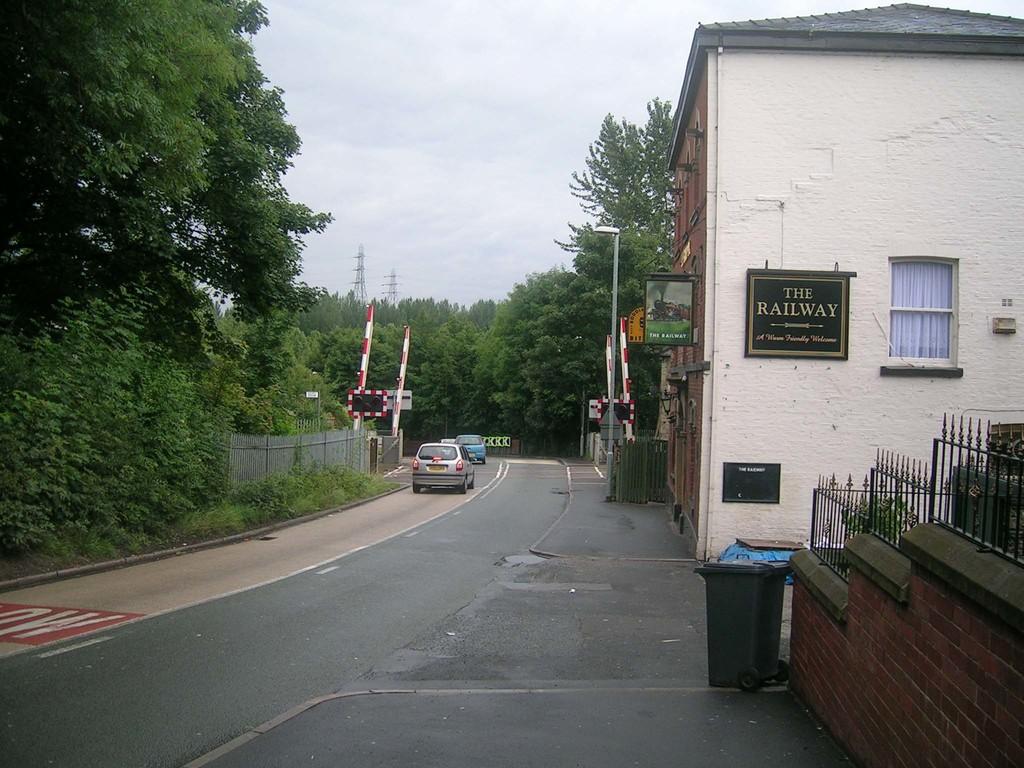What is the name of the building?
Give a very brief answer. The railway. 